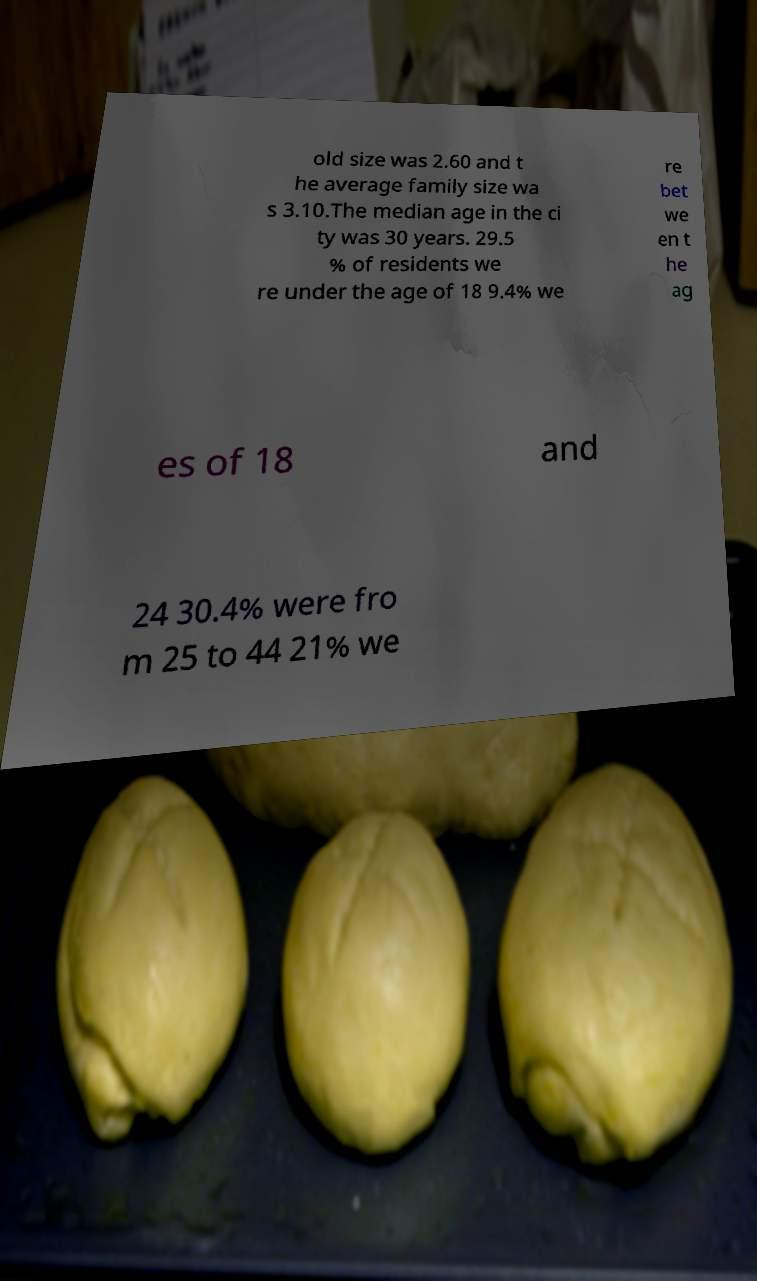For documentation purposes, I need the text within this image transcribed. Could you provide that? old size was 2.60 and t he average family size wa s 3.10.The median age in the ci ty was 30 years. 29.5 % of residents we re under the age of 18 9.4% we re bet we en t he ag es of 18 and 24 30.4% were fro m 25 to 44 21% we 